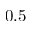Convert formula to latex. <formula><loc_0><loc_0><loc_500><loc_500>0 . 5</formula> 